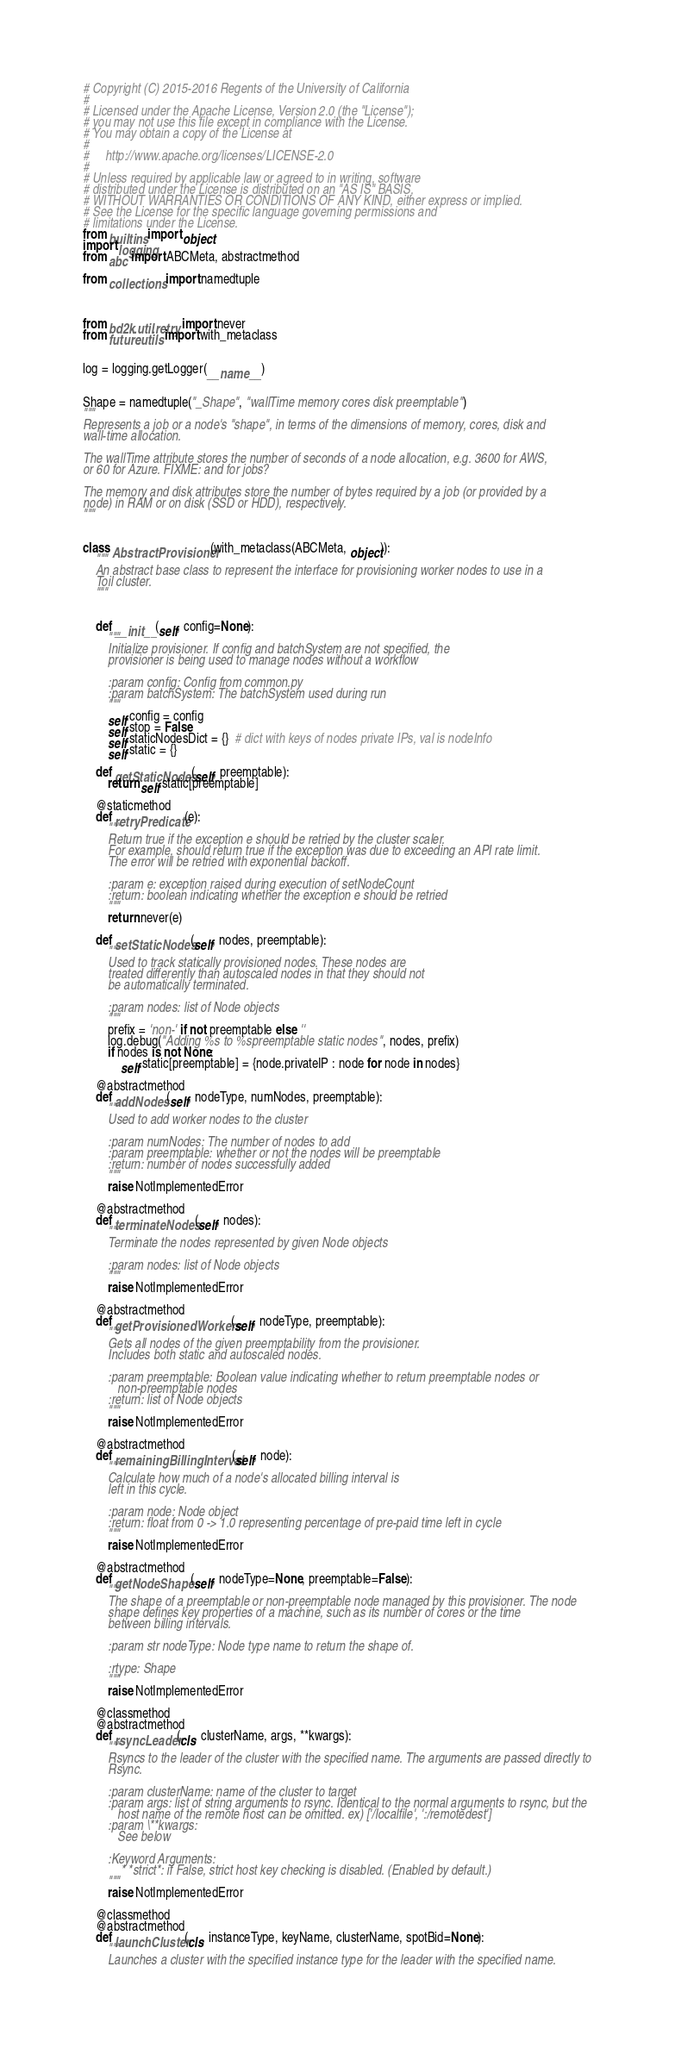<code> <loc_0><loc_0><loc_500><loc_500><_Python_># Copyright (C) 2015-2016 Regents of the University of California
#
# Licensed under the Apache License, Version 2.0 (the "License");
# you may not use this file except in compliance with the License.
# You may obtain a copy of the License at
#
#     http://www.apache.org/licenses/LICENSE-2.0
#
# Unless required by applicable law or agreed to in writing, software
# distributed under the License is distributed on an "AS IS" BASIS,
# WITHOUT WARRANTIES OR CONDITIONS OF ANY KIND, either express or implied.
# See the License for the specific language governing permissions and
# limitations under the License.
from builtins import object
import logging
from abc import ABCMeta, abstractmethod

from collections import namedtuple



from bd2k.util.retry import never
from future.utils import with_metaclass


log = logging.getLogger(__name__)


Shape = namedtuple("_Shape", "wallTime memory cores disk preemptable")
"""
Represents a job or a node's "shape", in terms of the dimensions of memory, cores, disk and
wall-time allocation.

The wallTime attribute stores the number of seconds of a node allocation, e.g. 3600 for AWS,
or 60 for Azure. FIXME: and for jobs?

The memory and disk attributes store the number of bytes required by a job (or provided by a
node) in RAM or on disk (SSD or HDD), respectively.
"""


class AbstractProvisioner(with_metaclass(ABCMeta, object)):
    """
    An abstract base class to represent the interface for provisioning worker nodes to use in a
    Toil cluster.
    """


    def __init__(self, config=None):
        """
        Initialize provisioner. If config and batchSystem are not specified, the
        provisioner is being used to manage nodes without a workflow

        :param config: Config from common.py
        :param batchSystem: The batchSystem used during run
        """
        self.config = config
        self.stop = False
        self.staticNodesDict = {}  # dict with keys of nodes private IPs, val is nodeInfo
        self.static = {}

    def getStaticNodes(self, preemptable):
        return self.static[preemptable]

    @staticmethod
    def retryPredicate(e):
        """
        Return true if the exception e should be retried by the cluster scaler.
        For example, should return true if the exception was due to exceeding an API rate limit.
        The error will be retried with exponential backoff.

        :param e: exception raised during execution of setNodeCount
        :return: boolean indicating whether the exception e should be retried
        """
        return never(e)

    def setStaticNodes(self, nodes, preemptable):
        """
        Used to track statically provisioned nodes. These nodes are
        treated differently than autoscaled nodes in that they should not
        be automatically terminated.

        :param nodes: list of Node objects
        """
        prefix = 'non-' if not preemptable else ''
        log.debug("Adding %s to %spreemptable static nodes", nodes, prefix)
        if nodes is not None:
            self.static[preemptable] = {node.privateIP : node for node in nodes}

    @abstractmethod
    def addNodes(self, nodeType, numNodes, preemptable):
        """
        Used to add worker nodes to the cluster

        :param numNodes: The number of nodes to add
        :param preemptable: whether or not the nodes will be preemptable
        :return: number of nodes successfully added
        """
        raise NotImplementedError

    @abstractmethod
    def terminateNodes(self, nodes):
        """
        Terminate the nodes represented by given Node objects

        :param nodes: list of Node objects
        """
        raise NotImplementedError

    @abstractmethod
    def getProvisionedWorkers(self, nodeType, preemptable):
        """
        Gets all nodes of the given preemptability from the provisioner.
        Includes both static and autoscaled nodes.

        :param preemptable: Boolean value indicating whether to return preemptable nodes or
           non-preemptable nodes
        :return: list of Node objects
        """
        raise NotImplementedError

    @abstractmethod
    def remainingBillingInterval(self, node):
        """
        Calculate how much of a node's allocated billing interval is
        left in this cycle.

        :param node: Node object
        :return: float from 0 -> 1.0 representing percentage of pre-paid time left in cycle
        """
        raise NotImplementedError

    @abstractmethod
    def getNodeShape(self, nodeType=None, preemptable=False):
        """
        The shape of a preemptable or non-preemptable node managed by this provisioner. The node
        shape defines key properties of a machine, such as its number of cores or the time
        between billing intervals.

        :param str nodeType: Node type name to return the shape of.

        :rtype: Shape
        """
        raise NotImplementedError

    @classmethod
    @abstractmethod
    def rsyncLeader(cls, clusterName, args, **kwargs):
        """
        Rsyncs to the leader of the cluster with the specified name. The arguments are passed directly to
        Rsync.

        :param clusterName: name of the cluster to target
        :param args: list of string arguments to rsync. Identical to the normal arguments to rsync, but the
           host name of the remote host can be omitted. ex) ['/localfile', ':/remotedest']
        :param \**kwargs:
           See below

        :Keyword Arguments:
            * *strict*: if False, strict host key checking is disabled. (Enabled by default.)
        """
        raise NotImplementedError

    @classmethod
    @abstractmethod
    def launchCluster(cls, instanceType, keyName, clusterName, spotBid=None):
        """
        Launches a cluster with the specified instance type for the leader with the specified name.
</code> 